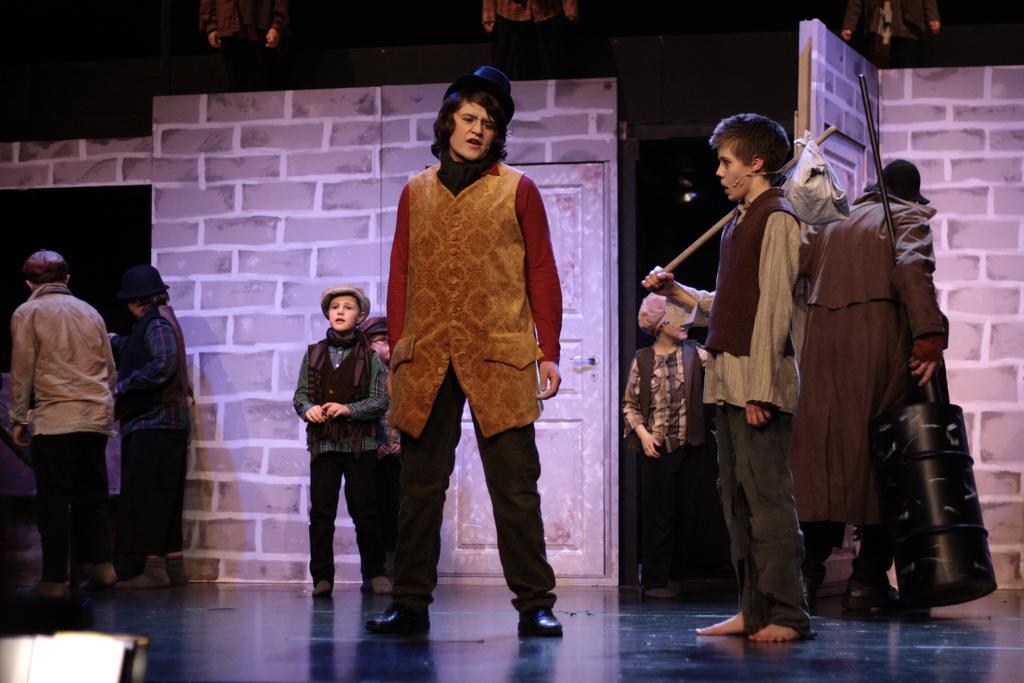Please provide a concise description of this image. In this picture we can see groups of people standing on the stage and two persons holding two objects. At the top of the image, there are three persons and a dark background. 